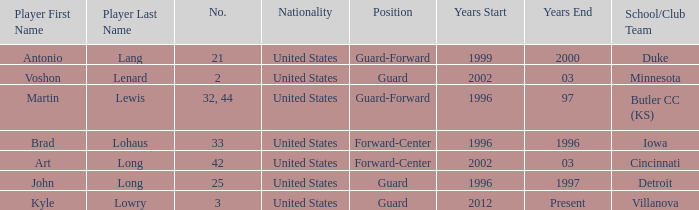What player played guard for toronto in 1996-97? John Long. 